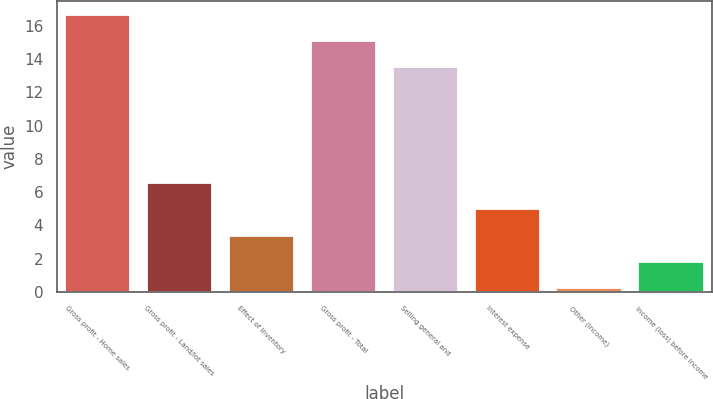Convert chart to OTSL. <chart><loc_0><loc_0><loc_500><loc_500><bar_chart><fcel>Gross profit - Home sales<fcel>Gross profit - Land/lot sales<fcel>Effect of inventory<fcel>Gross profit - Total<fcel>Selling general and<fcel>Interest expense<fcel>Other (income)<fcel>Income (loss) before income<nl><fcel>16.68<fcel>6.56<fcel>3.38<fcel>15.09<fcel>13.5<fcel>4.97<fcel>0.2<fcel>1.79<nl></chart> 